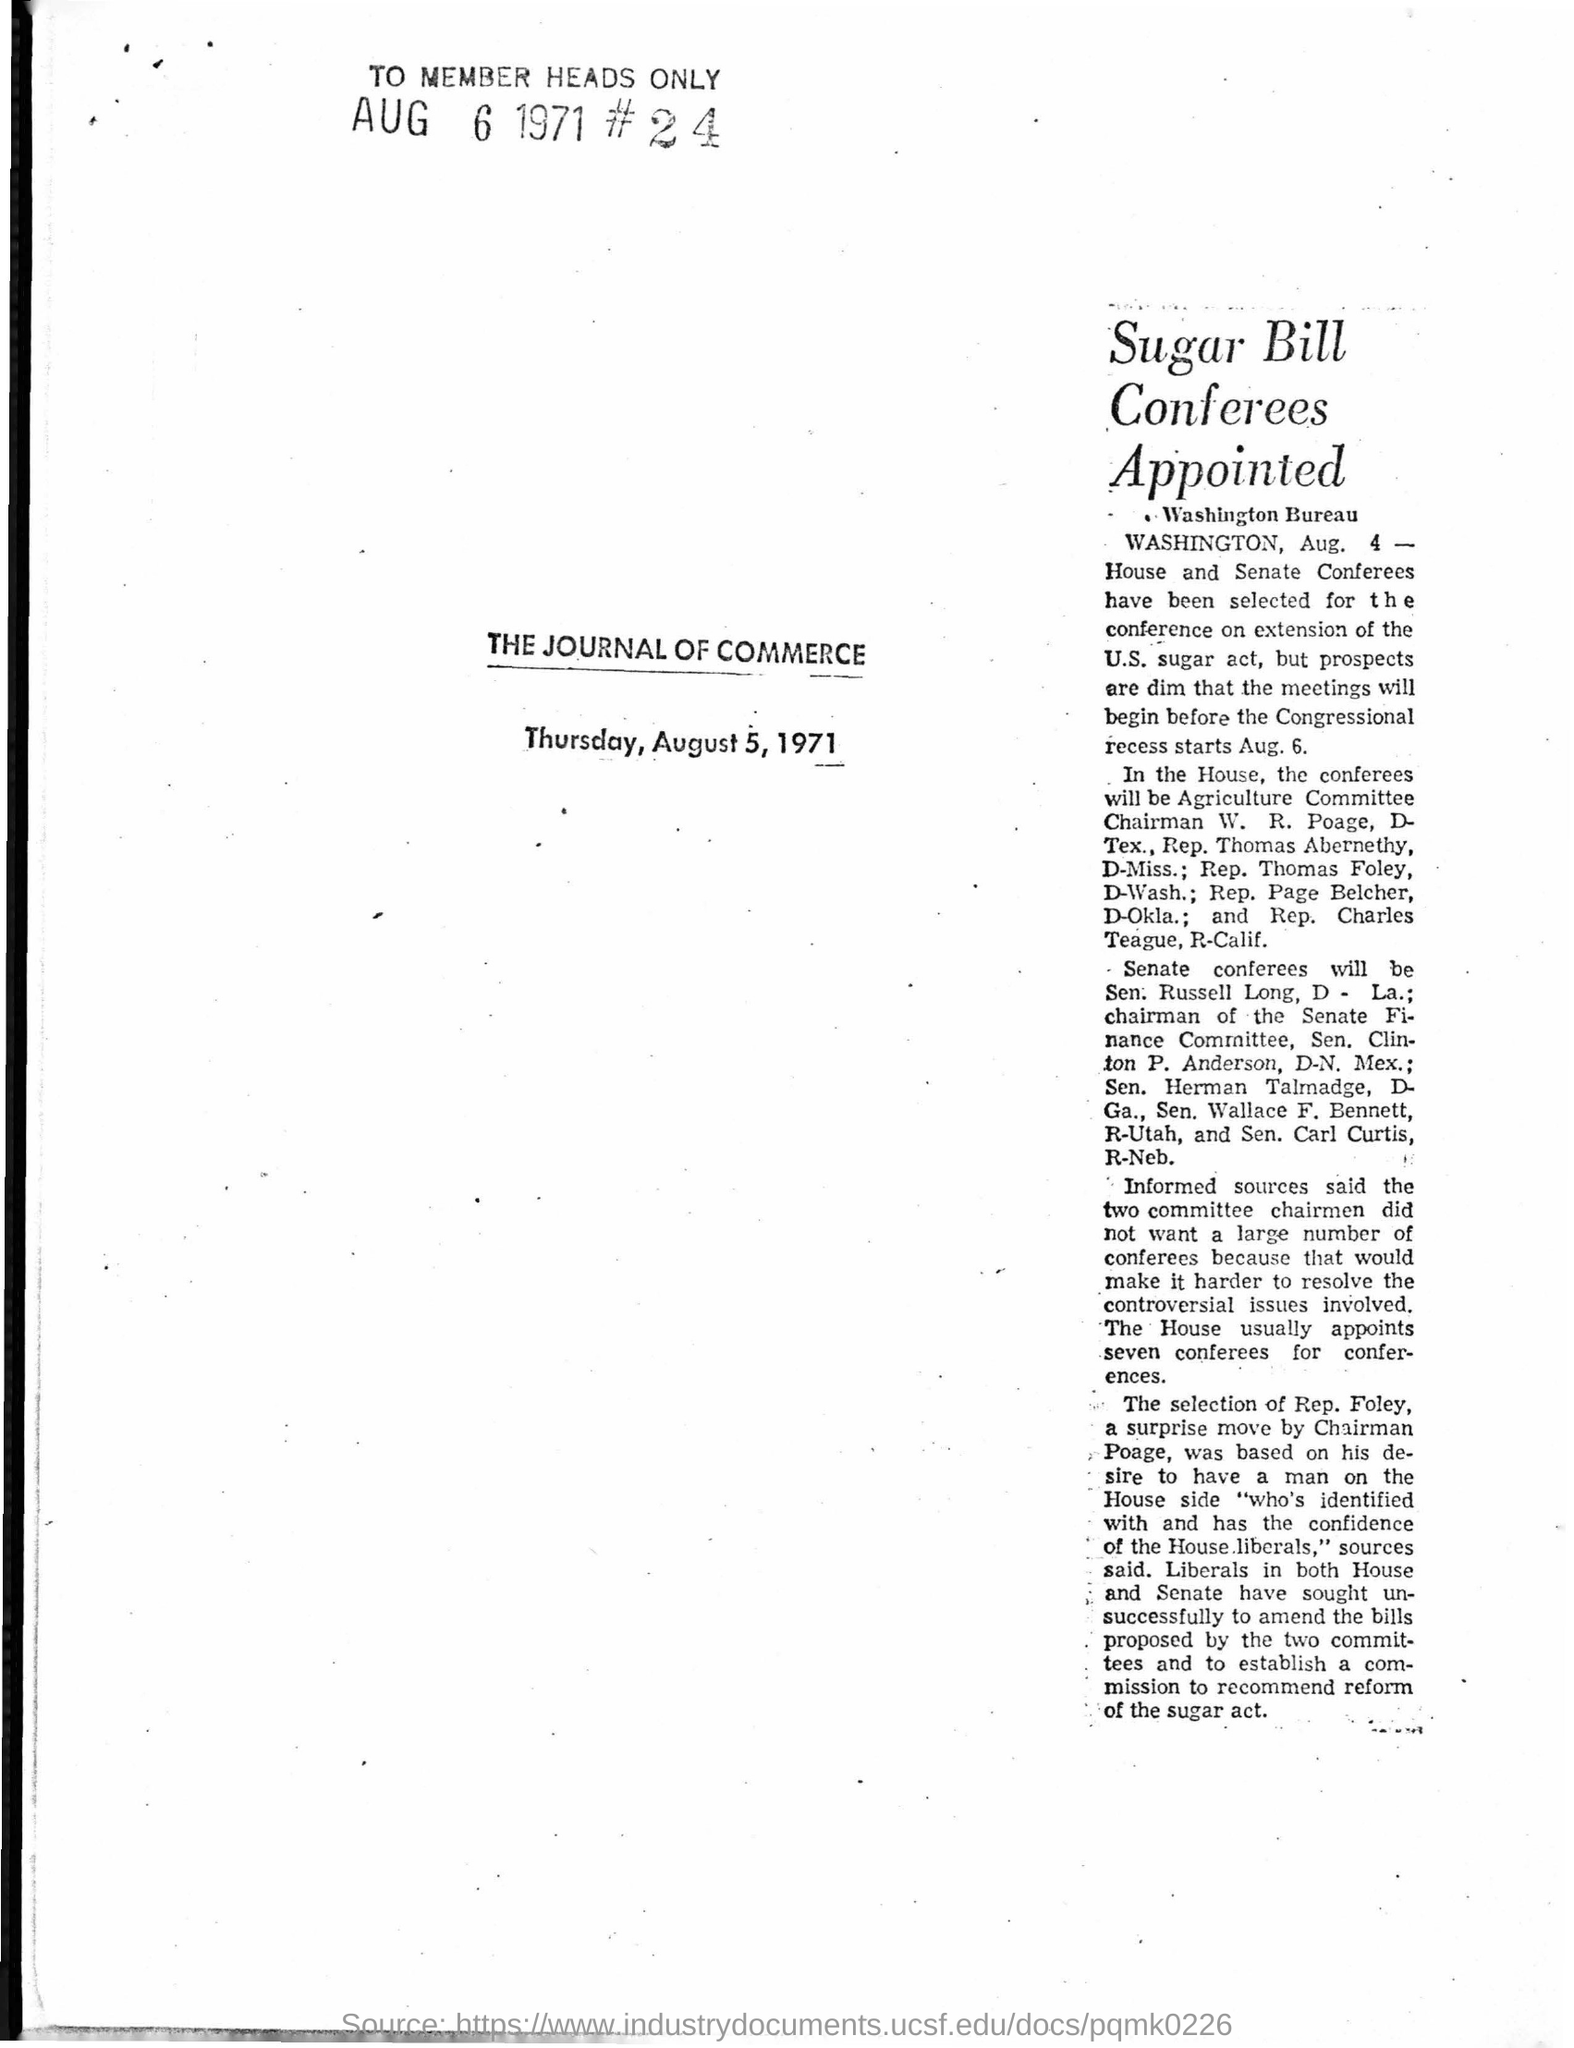When was the article printed?
Ensure brevity in your answer.  Thursday, August 5, 1971. 